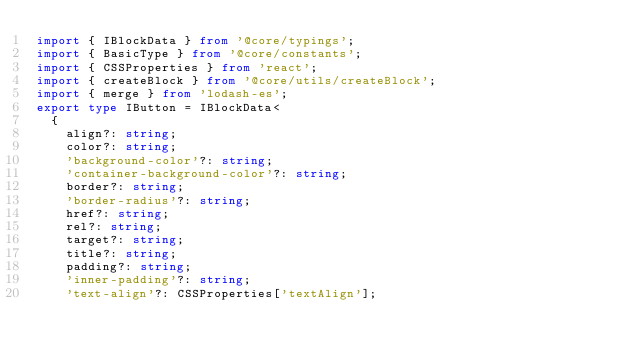<code> <loc_0><loc_0><loc_500><loc_500><_TypeScript_>import { IBlockData } from '@core/typings';
import { BasicType } from '@core/constants';
import { CSSProperties } from 'react';
import { createBlock } from '@core/utils/createBlock';
import { merge } from 'lodash-es';
export type IButton = IBlockData<
  {
    align?: string;
    color?: string;
    'background-color'?: string;
    'container-background-color'?: string;
    border?: string;
    'border-radius'?: string;
    href?: string;
    rel?: string;
    target?: string;
    title?: string;
    padding?: string;
    'inner-padding'?: string;
    'text-align'?: CSSProperties['textAlign'];</code> 